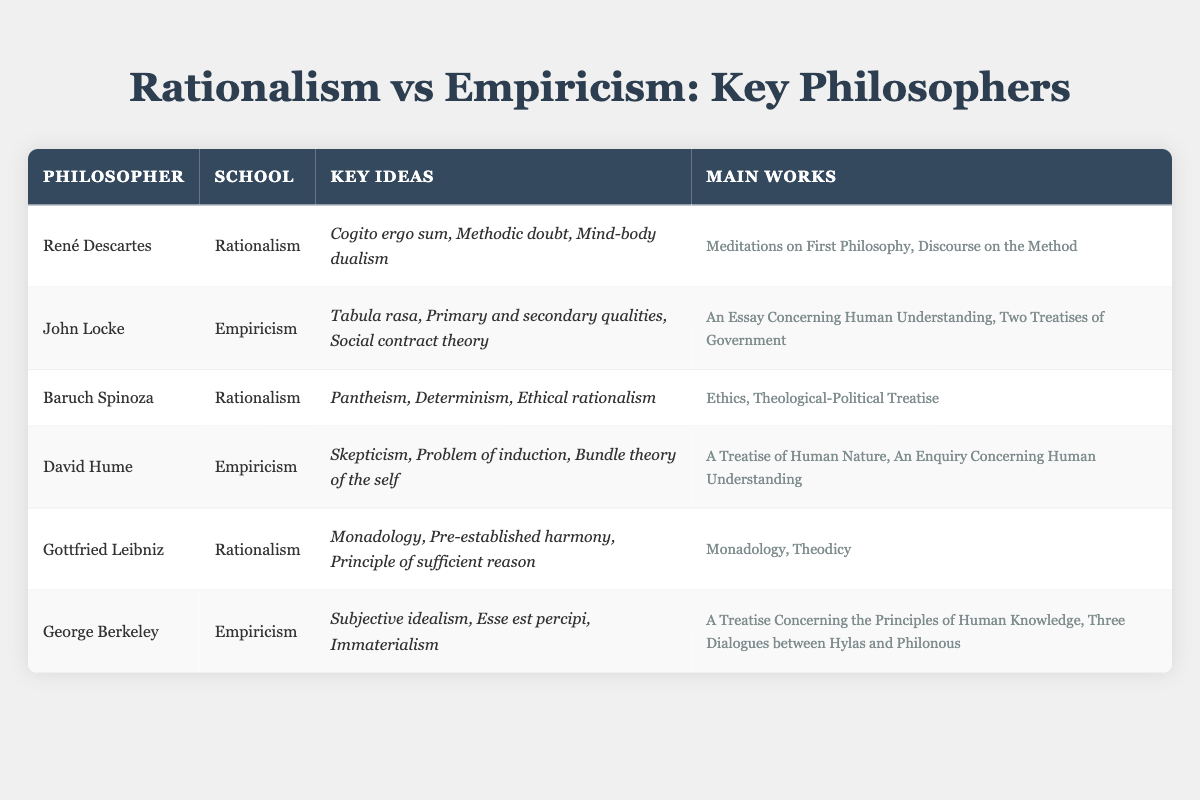What are the key ideas associated with René Descartes? The table indicates that René Descartes' key ideas include "Cogito ergo sum, Methodic doubt, Mind-body dualism." These were outlined in his significant works.
Answer: Cogito ergo sum, Methodic doubt, Mind-body dualism Who is the philosopher known for the concept of "Tabula rasa"? The table reveals that "Tabula rasa" is a key idea associated with John Locke, categorized under the school of Empiricism.
Answer: John Locke How many empiricist philosophers are listed in the table? The table shows that there are three empiricist philosophers: John Locke, David Hume, and George Berkeley. This can be confirmed by counting the rows that belong to the Empiricism school.
Answer: 3 Which philosopher’s works include "Ethics"? According to the table, Baruch Spinoza is credited with "Ethics" as one of his main works, indicating his belonging to the Rationalism school.
Answer: Baruch Spinoza Are there more rationalist philosophers or empiricist philosophers in the table? The table lists three rationalist philosophers (René Descartes, Baruch Spinoza, Gottfried Leibniz) and three empiricist philosophers (John Locke, David Hume, George Berkeley). Thus, both schools have the same number of philosophers.
Answer: No, they are equal 